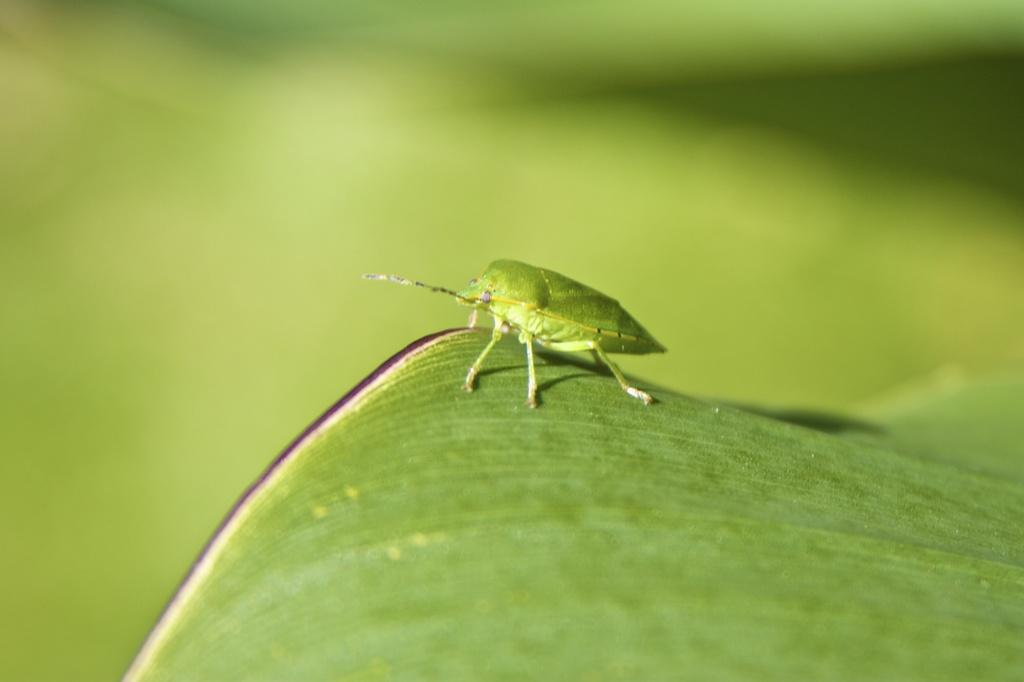What is present in the image? There is a bug in the image. What color is the bug? The bug is green in color. What is the bug standing on? The bug is standing on a leaf. What color is the leaf? The leaf is green in color. Can you see a badge on the bug in the image? There is no badge present on the bug in the image. How does the bug use its chin to communicate with the leaf? Bugs do not have chins, and they do not communicate with leaves in this manner. 